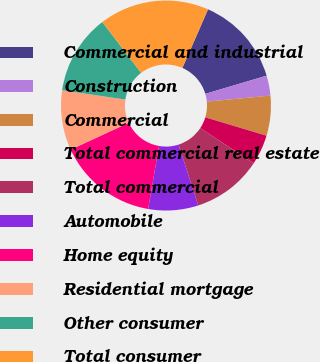<chart> <loc_0><loc_0><loc_500><loc_500><pie_chart><fcel>Commercial and industrial<fcel>Construction<fcel>Commercial<fcel>Total commercial real estate<fcel>Total commercial<fcel>Automobile<fcel>Home equity<fcel>Residential mortgage<fcel>Other consumer<fcel>Total consumer<nl><fcel>13.85%<fcel>3.08%<fcel>6.15%<fcel>4.62%<fcel>10.77%<fcel>7.69%<fcel>15.38%<fcel>9.23%<fcel>12.31%<fcel>16.92%<nl></chart> 